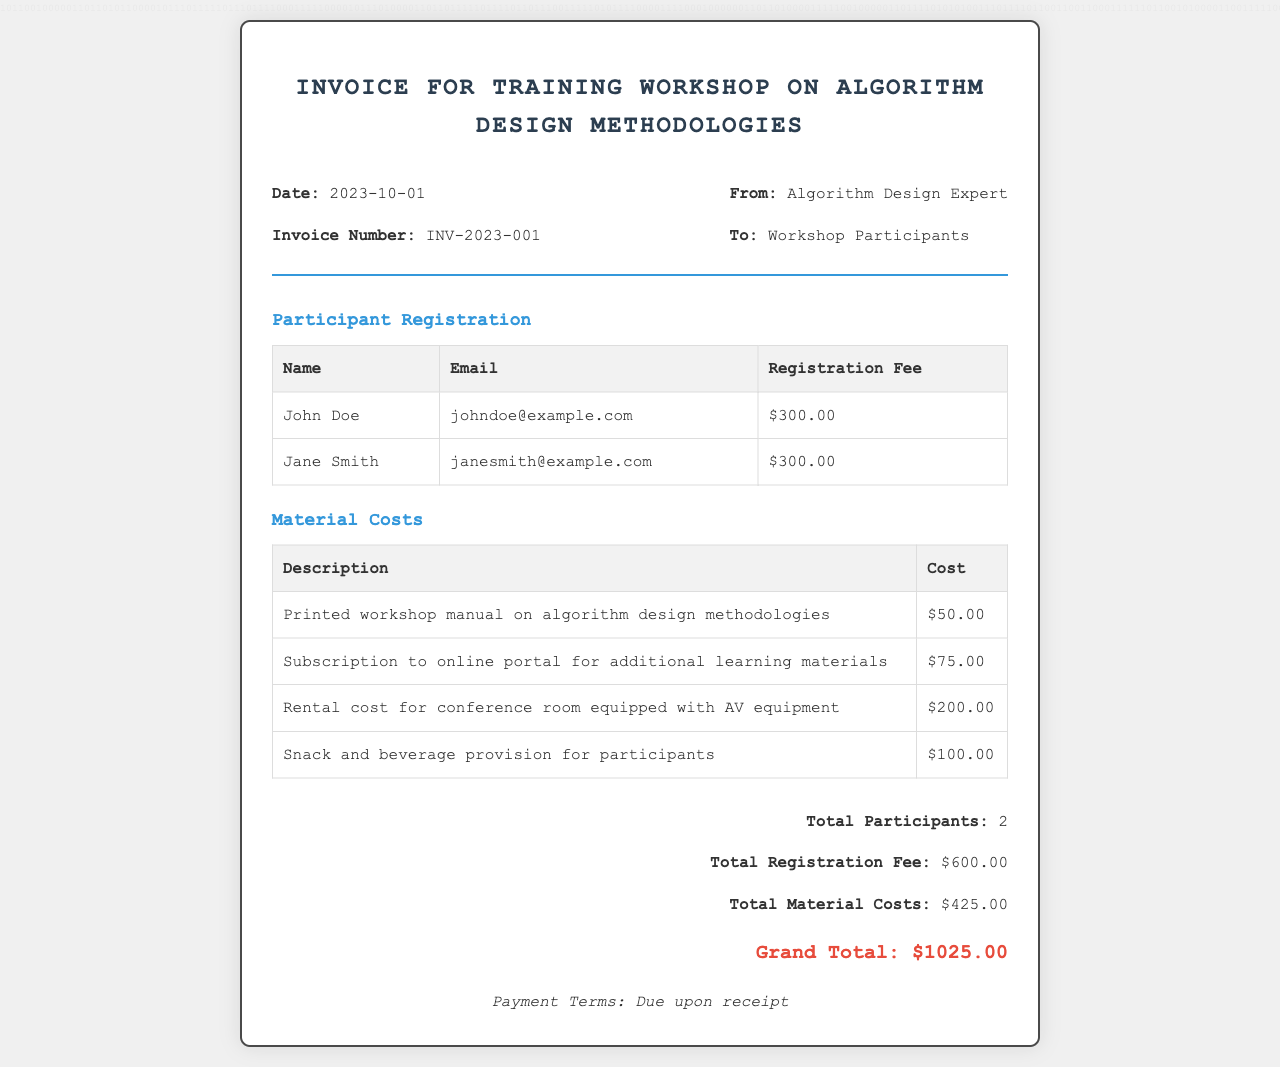What is the invoice number? The invoice number is specified in the document under the invoice header section.
Answer: INV-2023-001 What is the date of the invoice? The date is provided in the invoice header, indicating when the invoice was issued.
Answer: 2023-10-01 How many participants registered for the workshop? The number of participants is summarized in the invoice's summary section.
Answer: 2 What is the total material cost? The total material cost is calculated from the individual costs listed under the material costs section.
Answer: $425.00 What is the total registration fee? The total registration fee is found in the summary section, which outlines all fees collected.
Answer: $600.00 What is the grand total amount? The grand total is calculated by adding the total registration fee and the total material costs.
Answer: $1025.00 Who is the invoice addressed to? The recipient of the invoice can be found in the invoice header section.
Answer: Workshop Participants What is included in the material costs? The material costs section lists items with their costs contributing to total material expenses.
Answer: Printed workshop manual, subscription, room rental, snacks What are the payment terms? The payment terms state when payment is due and are mentioned in a specific section at the end.
Answer: Due upon receipt 